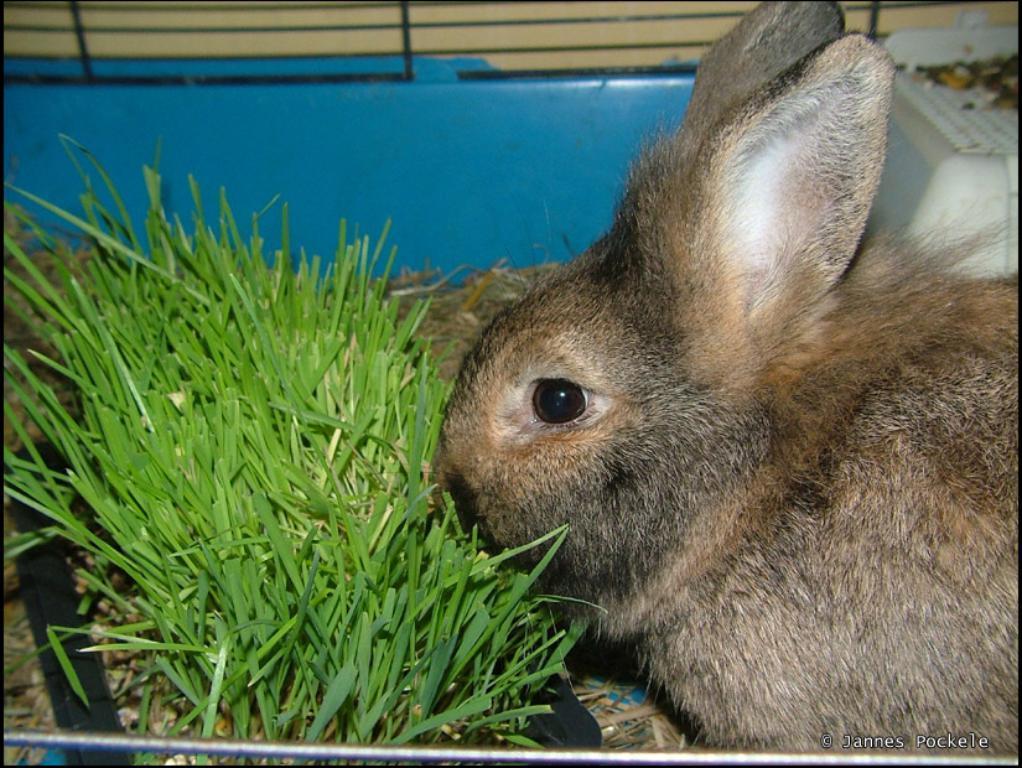Can you describe this image briefly? In the center of the image we can see grass and one squirrel, which is in black and brown color. In the bottom of the image, we can see one rod and some text. In the background there is a wall, white color object and a few other objects. 